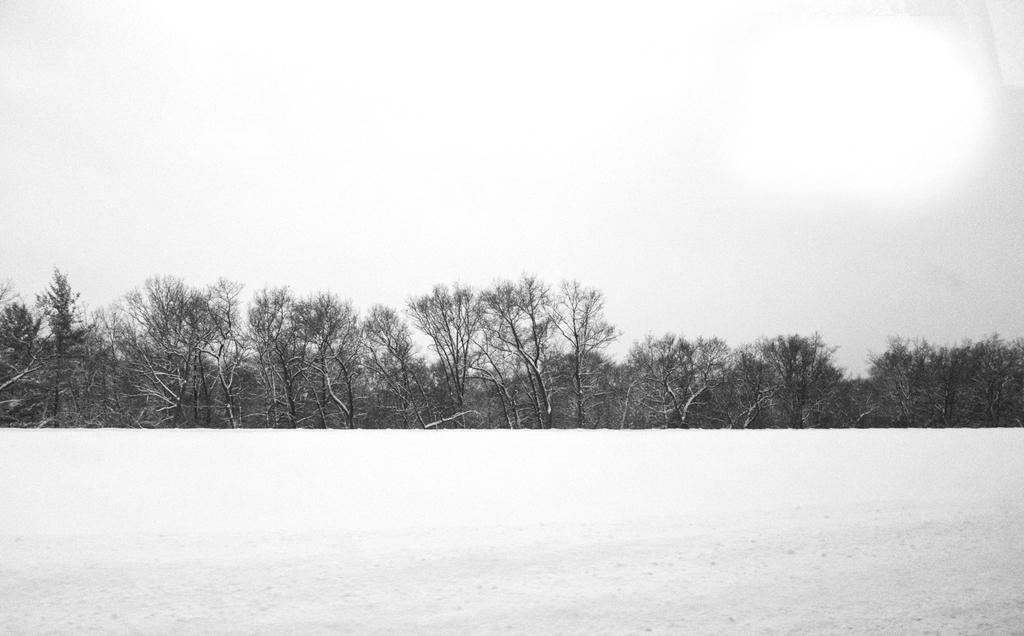What type of weather condition is depicted in the image? There is snow in the image, indicating a winter scene. What natural elements can be seen in the image? There are trees in the image. What can be seen in the background of the image? The sky is visible in the background of the image. Where is the drain located in the image? There is no drain present in the image. What type of field can be seen in the image? There is no field present in the image; it features snow and trees. 